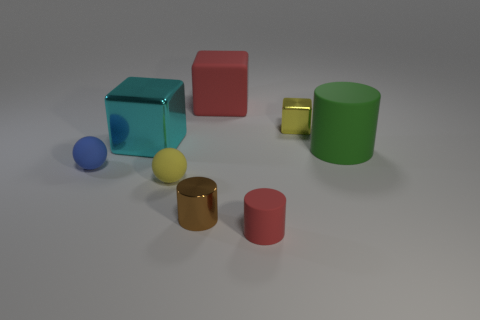Subtract all large cubes. How many cubes are left? 1 Add 2 shiny blocks. How many objects exist? 10 Subtract all balls. How many objects are left? 6 Subtract 1 yellow blocks. How many objects are left? 7 Subtract all large cyan rubber objects. Subtract all tiny yellow rubber spheres. How many objects are left? 7 Add 5 small cylinders. How many small cylinders are left? 7 Add 1 cylinders. How many cylinders exist? 4 